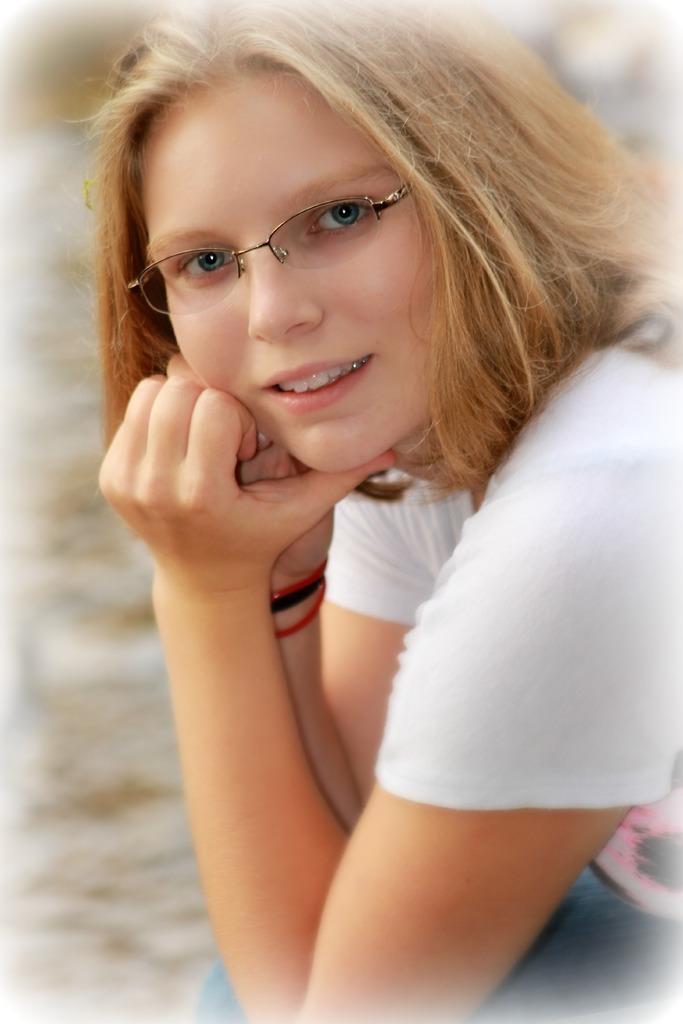How would you summarize this image in a sentence or two? This is an edited image. In the center of the image we can see a lady is sitting and wearing white T-shirt, jeans, spectacles. In the background, the image is blur. 